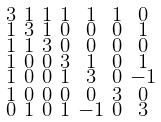Convert formula to latex. <formula><loc_0><loc_0><loc_500><loc_500>\begin{smallmatrix} 3 & 1 & 1 & 1 & 1 & 1 & 0 \\ 1 & 3 & 1 & 0 & 0 & 0 & 1 \\ 1 & 1 & 3 & 0 & 0 & 0 & 0 \\ 1 & 0 & 0 & 3 & 1 & 0 & 1 \\ 1 & 0 & 0 & 1 & 3 & 0 & - 1 \\ 1 & 0 & 0 & 0 & 0 & 3 & 0 \\ 0 & 1 & 0 & 1 & - 1 & 0 & 3 \end{smallmatrix}</formula> 